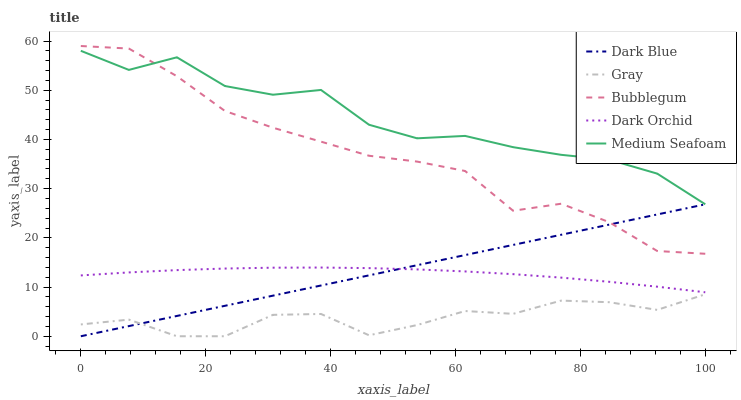Does Gray have the minimum area under the curve?
Answer yes or no. Yes. Does Medium Seafoam have the maximum area under the curve?
Answer yes or no. Yes. Does Dark Orchid have the minimum area under the curve?
Answer yes or no. No. Does Dark Orchid have the maximum area under the curve?
Answer yes or no. No. Is Dark Blue the smoothest?
Answer yes or no. Yes. Is Medium Seafoam the roughest?
Answer yes or no. Yes. Is Dark Orchid the smoothest?
Answer yes or no. No. Is Dark Orchid the roughest?
Answer yes or no. No. Does Dark Blue have the lowest value?
Answer yes or no. Yes. Does Dark Orchid have the lowest value?
Answer yes or no. No. Does Bubblegum have the highest value?
Answer yes or no. Yes. Does Medium Seafoam have the highest value?
Answer yes or no. No. Is Gray less than Medium Seafoam?
Answer yes or no. Yes. Is Medium Seafoam greater than Dark Blue?
Answer yes or no. Yes. Does Medium Seafoam intersect Bubblegum?
Answer yes or no. Yes. Is Medium Seafoam less than Bubblegum?
Answer yes or no. No. Is Medium Seafoam greater than Bubblegum?
Answer yes or no. No. Does Gray intersect Medium Seafoam?
Answer yes or no. No. 